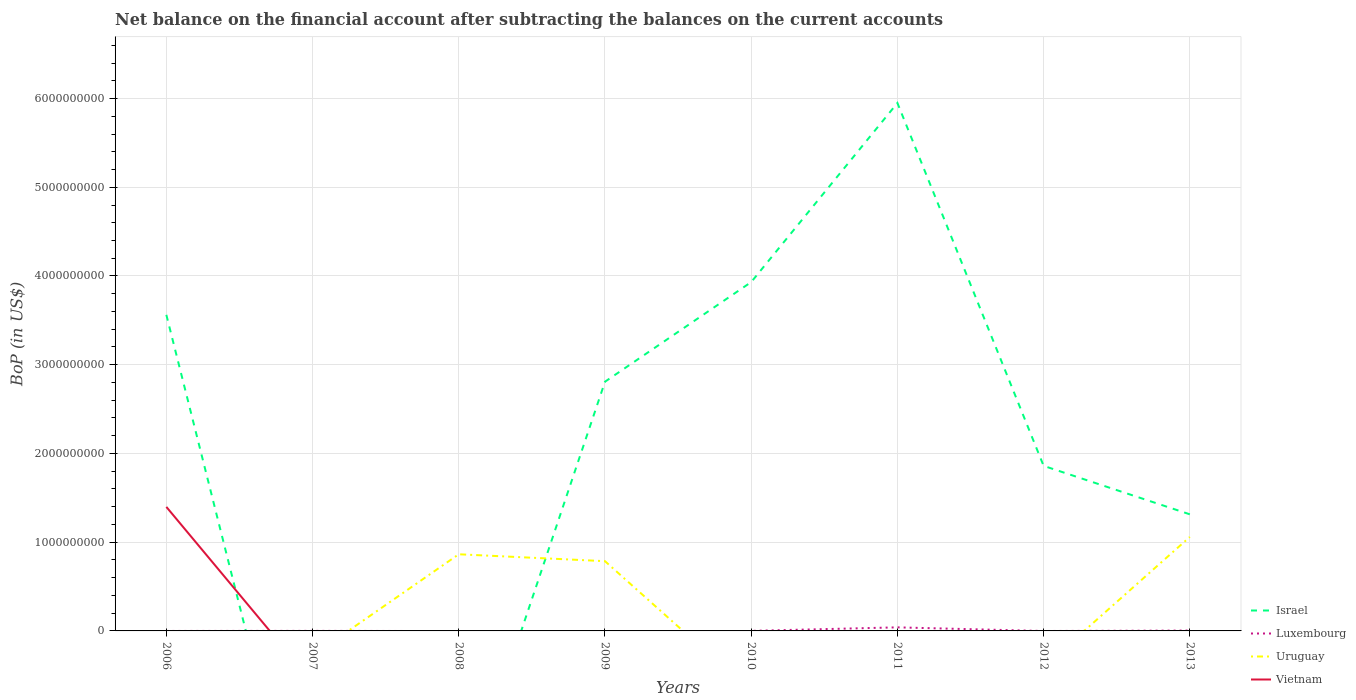Across all years, what is the maximum Balance of Payments in Vietnam?
Your response must be concise. 0. What is the total Balance of Payments in Israel in the graph?
Your answer should be very brief. -3.14e+09. What is the difference between the highest and the second highest Balance of Payments in Israel?
Your response must be concise. 5.95e+09. What is the difference between the highest and the lowest Balance of Payments in Vietnam?
Provide a succinct answer. 1. How many lines are there?
Offer a very short reply. 4. Does the graph contain any zero values?
Your response must be concise. Yes. Where does the legend appear in the graph?
Make the answer very short. Bottom right. How are the legend labels stacked?
Your answer should be very brief. Vertical. What is the title of the graph?
Your response must be concise. Net balance on the financial account after subtracting the balances on the current accounts. Does "Poland" appear as one of the legend labels in the graph?
Offer a terse response. No. What is the label or title of the X-axis?
Ensure brevity in your answer.  Years. What is the label or title of the Y-axis?
Your answer should be very brief. BoP (in US$). What is the BoP (in US$) in Israel in 2006?
Your response must be concise. 3.56e+09. What is the BoP (in US$) in Uruguay in 2006?
Ensure brevity in your answer.  0. What is the BoP (in US$) in Vietnam in 2006?
Provide a short and direct response. 1.40e+09. What is the BoP (in US$) of Luxembourg in 2007?
Provide a short and direct response. 4.90e+05. What is the BoP (in US$) in Vietnam in 2007?
Make the answer very short. 0. What is the BoP (in US$) in Luxembourg in 2008?
Offer a very short reply. 0. What is the BoP (in US$) of Uruguay in 2008?
Your answer should be very brief. 8.64e+08. What is the BoP (in US$) of Israel in 2009?
Ensure brevity in your answer.  2.81e+09. What is the BoP (in US$) in Luxembourg in 2009?
Offer a very short reply. 0. What is the BoP (in US$) in Uruguay in 2009?
Make the answer very short. 7.86e+08. What is the BoP (in US$) in Vietnam in 2009?
Provide a short and direct response. 0. What is the BoP (in US$) of Israel in 2010?
Provide a succinct answer. 3.93e+09. What is the BoP (in US$) in Luxembourg in 2010?
Keep it short and to the point. 6.25e+05. What is the BoP (in US$) in Israel in 2011?
Your response must be concise. 5.95e+09. What is the BoP (in US$) of Luxembourg in 2011?
Offer a terse response. 4.02e+07. What is the BoP (in US$) of Uruguay in 2011?
Provide a short and direct response. 0. What is the BoP (in US$) in Israel in 2012?
Offer a terse response. 1.86e+09. What is the BoP (in US$) of Luxembourg in 2012?
Offer a very short reply. 0. What is the BoP (in US$) in Uruguay in 2012?
Keep it short and to the point. 0. What is the BoP (in US$) of Vietnam in 2012?
Provide a short and direct response. 0. What is the BoP (in US$) of Israel in 2013?
Make the answer very short. 1.31e+09. What is the BoP (in US$) of Luxembourg in 2013?
Your answer should be compact. 4.16e+06. What is the BoP (in US$) of Uruguay in 2013?
Your response must be concise. 1.06e+09. Across all years, what is the maximum BoP (in US$) of Israel?
Provide a succinct answer. 5.95e+09. Across all years, what is the maximum BoP (in US$) of Luxembourg?
Offer a terse response. 4.02e+07. Across all years, what is the maximum BoP (in US$) of Uruguay?
Offer a very short reply. 1.06e+09. Across all years, what is the maximum BoP (in US$) of Vietnam?
Make the answer very short. 1.40e+09. Across all years, what is the minimum BoP (in US$) of Israel?
Your answer should be very brief. 0. Across all years, what is the minimum BoP (in US$) of Uruguay?
Your answer should be compact. 0. Across all years, what is the minimum BoP (in US$) in Vietnam?
Ensure brevity in your answer.  0. What is the total BoP (in US$) of Israel in the graph?
Your response must be concise. 1.94e+1. What is the total BoP (in US$) of Luxembourg in the graph?
Ensure brevity in your answer.  4.54e+07. What is the total BoP (in US$) in Uruguay in the graph?
Keep it short and to the point. 2.71e+09. What is the total BoP (in US$) of Vietnam in the graph?
Give a very brief answer. 1.40e+09. What is the difference between the BoP (in US$) of Israel in 2006 and that in 2009?
Your answer should be very brief. 7.54e+08. What is the difference between the BoP (in US$) of Israel in 2006 and that in 2010?
Provide a short and direct response. -3.69e+08. What is the difference between the BoP (in US$) of Israel in 2006 and that in 2011?
Your answer should be very brief. -2.39e+09. What is the difference between the BoP (in US$) of Israel in 2006 and that in 2012?
Offer a terse response. 1.70e+09. What is the difference between the BoP (in US$) of Israel in 2006 and that in 2013?
Your response must be concise. 2.25e+09. What is the difference between the BoP (in US$) of Luxembourg in 2007 and that in 2010?
Provide a short and direct response. -1.34e+05. What is the difference between the BoP (in US$) of Luxembourg in 2007 and that in 2011?
Provide a succinct answer. -3.97e+07. What is the difference between the BoP (in US$) of Luxembourg in 2007 and that in 2013?
Your response must be concise. -3.67e+06. What is the difference between the BoP (in US$) in Uruguay in 2008 and that in 2009?
Offer a very short reply. 7.78e+07. What is the difference between the BoP (in US$) of Uruguay in 2008 and that in 2013?
Your response must be concise. -1.95e+08. What is the difference between the BoP (in US$) in Israel in 2009 and that in 2010?
Offer a terse response. -1.12e+09. What is the difference between the BoP (in US$) in Israel in 2009 and that in 2011?
Ensure brevity in your answer.  -3.14e+09. What is the difference between the BoP (in US$) of Israel in 2009 and that in 2012?
Offer a terse response. 9.48e+08. What is the difference between the BoP (in US$) of Israel in 2009 and that in 2013?
Ensure brevity in your answer.  1.49e+09. What is the difference between the BoP (in US$) of Uruguay in 2009 and that in 2013?
Make the answer very short. -2.73e+08. What is the difference between the BoP (in US$) in Israel in 2010 and that in 2011?
Offer a very short reply. -2.02e+09. What is the difference between the BoP (in US$) of Luxembourg in 2010 and that in 2011?
Give a very brief answer. -3.95e+07. What is the difference between the BoP (in US$) in Israel in 2010 and that in 2012?
Offer a terse response. 2.07e+09. What is the difference between the BoP (in US$) in Israel in 2010 and that in 2013?
Provide a short and direct response. 2.62e+09. What is the difference between the BoP (in US$) of Luxembourg in 2010 and that in 2013?
Provide a short and direct response. -3.54e+06. What is the difference between the BoP (in US$) in Israel in 2011 and that in 2012?
Offer a terse response. 4.09e+09. What is the difference between the BoP (in US$) in Israel in 2011 and that in 2013?
Offer a very short reply. 4.64e+09. What is the difference between the BoP (in US$) of Luxembourg in 2011 and that in 2013?
Offer a very short reply. 3.60e+07. What is the difference between the BoP (in US$) in Israel in 2012 and that in 2013?
Your answer should be very brief. 5.46e+08. What is the difference between the BoP (in US$) of Israel in 2006 and the BoP (in US$) of Luxembourg in 2007?
Ensure brevity in your answer.  3.56e+09. What is the difference between the BoP (in US$) of Israel in 2006 and the BoP (in US$) of Uruguay in 2008?
Your answer should be compact. 2.70e+09. What is the difference between the BoP (in US$) of Israel in 2006 and the BoP (in US$) of Uruguay in 2009?
Your answer should be very brief. 2.78e+09. What is the difference between the BoP (in US$) of Israel in 2006 and the BoP (in US$) of Luxembourg in 2010?
Ensure brevity in your answer.  3.56e+09. What is the difference between the BoP (in US$) of Israel in 2006 and the BoP (in US$) of Luxembourg in 2011?
Ensure brevity in your answer.  3.52e+09. What is the difference between the BoP (in US$) in Israel in 2006 and the BoP (in US$) in Luxembourg in 2013?
Your response must be concise. 3.56e+09. What is the difference between the BoP (in US$) of Israel in 2006 and the BoP (in US$) of Uruguay in 2013?
Give a very brief answer. 2.50e+09. What is the difference between the BoP (in US$) of Luxembourg in 2007 and the BoP (in US$) of Uruguay in 2008?
Offer a very short reply. -8.63e+08. What is the difference between the BoP (in US$) in Luxembourg in 2007 and the BoP (in US$) in Uruguay in 2009?
Your answer should be very brief. -7.86e+08. What is the difference between the BoP (in US$) of Luxembourg in 2007 and the BoP (in US$) of Uruguay in 2013?
Give a very brief answer. -1.06e+09. What is the difference between the BoP (in US$) of Israel in 2009 and the BoP (in US$) of Luxembourg in 2010?
Keep it short and to the point. 2.81e+09. What is the difference between the BoP (in US$) in Israel in 2009 and the BoP (in US$) in Luxembourg in 2011?
Provide a succinct answer. 2.77e+09. What is the difference between the BoP (in US$) of Israel in 2009 and the BoP (in US$) of Luxembourg in 2013?
Provide a short and direct response. 2.80e+09. What is the difference between the BoP (in US$) of Israel in 2009 and the BoP (in US$) of Uruguay in 2013?
Make the answer very short. 1.75e+09. What is the difference between the BoP (in US$) of Israel in 2010 and the BoP (in US$) of Luxembourg in 2011?
Ensure brevity in your answer.  3.89e+09. What is the difference between the BoP (in US$) of Israel in 2010 and the BoP (in US$) of Luxembourg in 2013?
Your answer should be very brief. 3.93e+09. What is the difference between the BoP (in US$) in Israel in 2010 and the BoP (in US$) in Uruguay in 2013?
Offer a terse response. 2.87e+09. What is the difference between the BoP (in US$) in Luxembourg in 2010 and the BoP (in US$) in Uruguay in 2013?
Provide a succinct answer. -1.06e+09. What is the difference between the BoP (in US$) of Israel in 2011 and the BoP (in US$) of Luxembourg in 2013?
Give a very brief answer. 5.95e+09. What is the difference between the BoP (in US$) in Israel in 2011 and the BoP (in US$) in Uruguay in 2013?
Offer a very short reply. 4.89e+09. What is the difference between the BoP (in US$) in Luxembourg in 2011 and the BoP (in US$) in Uruguay in 2013?
Provide a short and direct response. -1.02e+09. What is the difference between the BoP (in US$) in Israel in 2012 and the BoP (in US$) in Luxembourg in 2013?
Provide a succinct answer. 1.86e+09. What is the difference between the BoP (in US$) in Israel in 2012 and the BoP (in US$) in Uruguay in 2013?
Provide a short and direct response. 8.01e+08. What is the average BoP (in US$) in Israel per year?
Offer a terse response. 2.43e+09. What is the average BoP (in US$) of Luxembourg per year?
Provide a short and direct response. 5.68e+06. What is the average BoP (in US$) in Uruguay per year?
Your answer should be very brief. 3.39e+08. What is the average BoP (in US$) in Vietnam per year?
Your answer should be very brief. 1.75e+08. In the year 2006, what is the difference between the BoP (in US$) of Israel and BoP (in US$) of Vietnam?
Offer a very short reply. 2.16e+09. In the year 2009, what is the difference between the BoP (in US$) in Israel and BoP (in US$) in Uruguay?
Ensure brevity in your answer.  2.02e+09. In the year 2010, what is the difference between the BoP (in US$) of Israel and BoP (in US$) of Luxembourg?
Your response must be concise. 3.93e+09. In the year 2011, what is the difference between the BoP (in US$) in Israel and BoP (in US$) in Luxembourg?
Give a very brief answer. 5.91e+09. In the year 2013, what is the difference between the BoP (in US$) in Israel and BoP (in US$) in Luxembourg?
Provide a short and direct response. 1.31e+09. In the year 2013, what is the difference between the BoP (in US$) of Israel and BoP (in US$) of Uruguay?
Your response must be concise. 2.55e+08. In the year 2013, what is the difference between the BoP (in US$) of Luxembourg and BoP (in US$) of Uruguay?
Give a very brief answer. -1.05e+09. What is the ratio of the BoP (in US$) in Israel in 2006 to that in 2009?
Ensure brevity in your answer.  1.27. What is the ratio of the BoP (in US$) in Israel in 2006 to that in 2010?
Provide a short and direct response. 0.91. What is the ratio of the BoP (in US$) of Israel in 2006 to that in 2011?
Provide a short and direct response. 0.6. What is the ratio of the BoP (in US$) in Israel in 2006 to that in 2012?
Make the answer very short. 1.92. What is the ratio of the BoP (in US$) in Israel in 2006 to that in 2013?
Make the answer very short. 2.71. What is the ratio of the BoP (in US$) in Luxembourg in 2007 to that in 2010?
Give a very brief answer. 0.79. What is the ratio of the BoP (in US$) in Luxembourg in 2007 to that in 2011?
Make the answer very short. 0.01. What is the ratio of the BoP (in US$) in Luxembourg in 2007 to that in 2013?
Ensure brevity in your answer.  0.12. What is the ratio of the BoP (in US$) in Uruguay in 2008 to that in 2009?
Your response must be concise. 1.1. What is the ratio of the BoP (in US$) of Uruguay in 2008 to that in 2013?
Keep it short and to the point. 0.82. What is the ratio of the BoP (in US$) in Israel in 2009 to that in 2010?
Your answer should be compact. 0.71. What is the ratio of the BoP (in US$) of Israel in 2009 to that in 2011?
Your answer should be compact. 0.47. What is the ratio of the BoP (in US$) of Israel in 2009 to that in 2012?
Your answer should be compact. 1.51. What is the ratio of the BoP (in US$) of Israel in 2009 to that in 2013?
Keep it short and to the point. 2.14. What is the ratio of the BoP (in US$) in Uruguay in 2009 to that in 2013?
Give a very brief answer. 0.74. What is the ratio of the BoP (in US$) of Israel in 2010 to that in 2011?
Your answer should be very brief. 0.66. What is the ratio of the BoP (in US$) in Luxembourg in 2010 to that in 2011?
Keep it short and to the point. 0.02. What is the ratio of the BoP (in US$) in Israel in 2010 to that in 2012?
Keep it short and to the point. 2.11. What is the ratio of the BoP (in US$) in Israel in 2010 to that in 2013?
Your response must be concise. 2.99. What is the ratio of the BoP (in US$) of Luxembourg in 2010 to that in 2013?
Make the answer very short. 0.15. What is the ratio of the BoP (in US$) of Israel in 2011 to that in 2012?
Your answer should be compact. 3.2. What is the ratio of the BoP (in US$) of Israel in 2011 to that in 2013?
Provide a succinct answer. 4.53. What is the ratio of the BoP (in US$) in Luxembourg in 2011 to that in 2013?
Your response must be concise. 9.65. What is the ratio of the BoP (in US$) of Israel in 2012 to that in 2013?
Your answer should be very brief. 1.42. What is the difference between the highest and the second highest BoP (in US$) in Israel?
Provide a succinct answer. 2.02e+09. What is the difference between the highest and the second highest BoP (in US$) of Luxembourg?
Provide a succinct answer. 3.60e+07. What is the difference between the highest and the second highest BoP (in US$) in Uruguay?
Offer a very short reply. 1.95e+08. What is the difference between the highest and the lowest BoP (in US$) in Israel?
Provide a short and direct response. 5.95e+09. What is the difference between the highest and the lowest BoP (in US$) in Luxembourg?
Your response must be concise. 4.02e+07. What is the difference between the highest and the lowest BoP (in US$) in Uruguay?
Your answer should be compact. 1.06e+09. What is the difference between the highest and the lowest BoP (in US$) in Vietnam?
Give a very brief answer. 1.40e+09. 